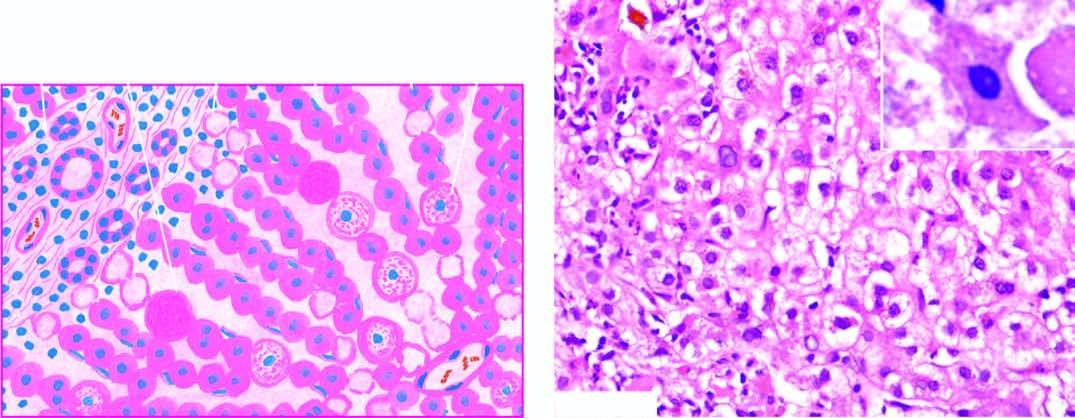s normal non-activated platelet, having open canalicular system and the cytoplasmic organelles seen as ballooning degeneration while acidophilic councilman bodies are indicative of more severe liver cell injury?
Answer the question using a single word or phrase. No 